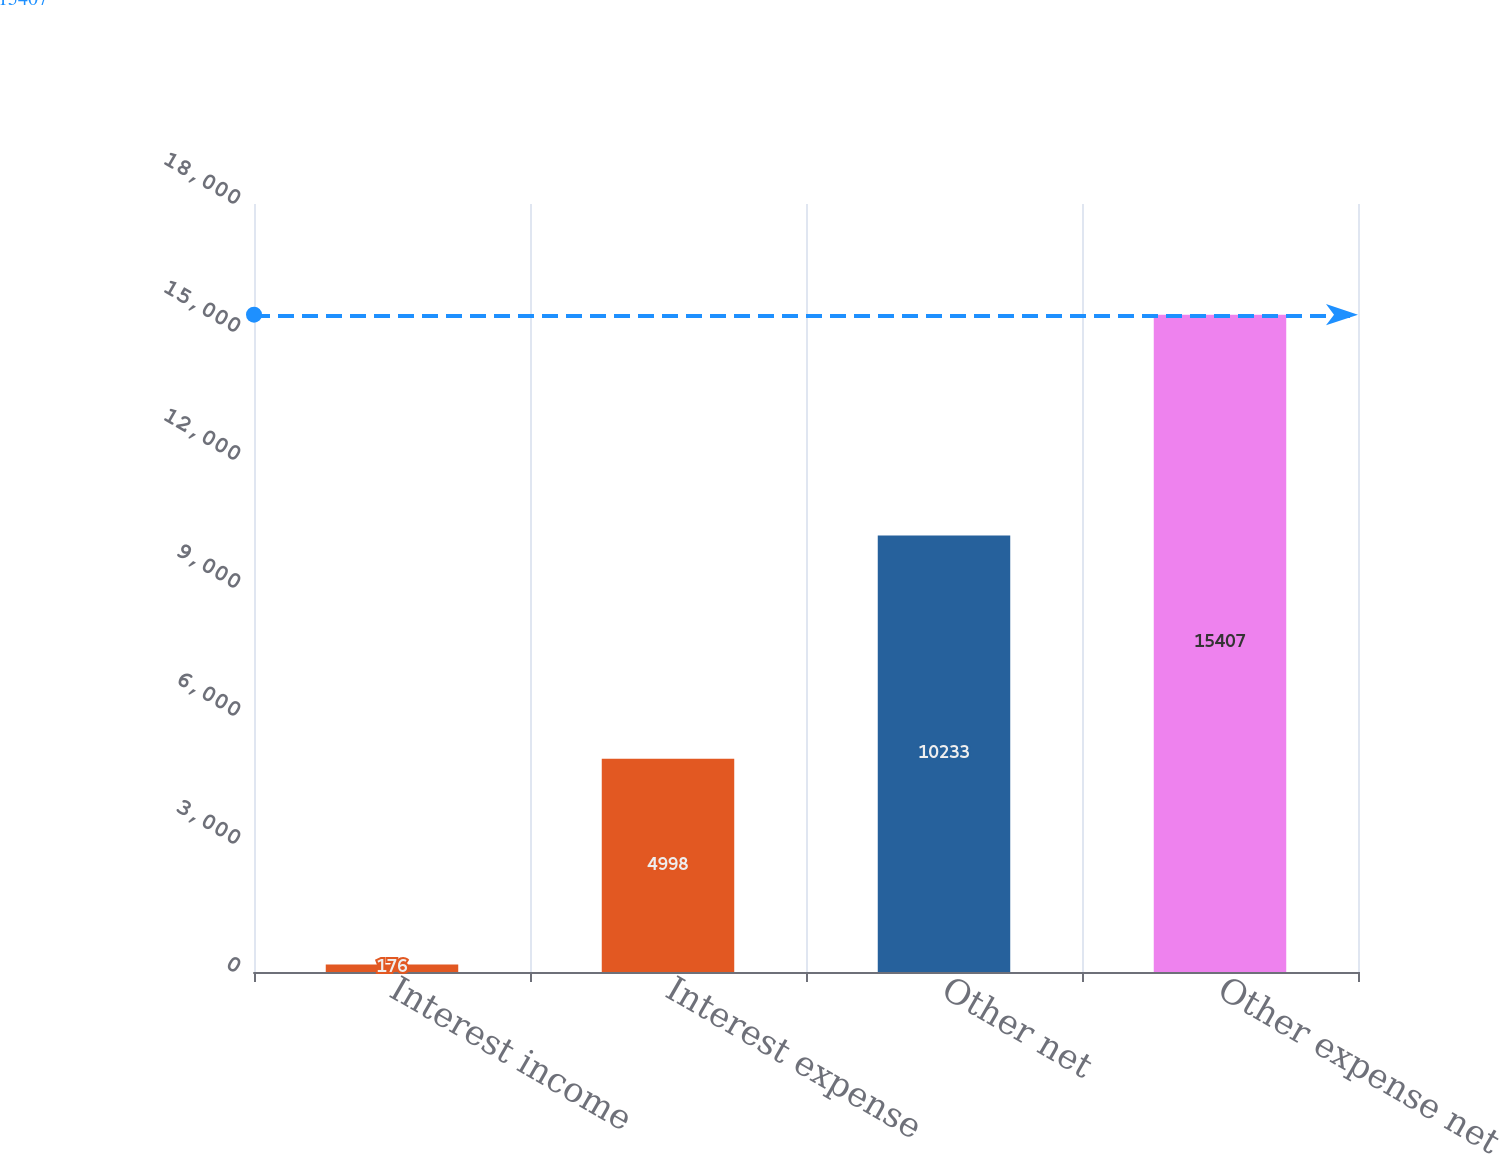<chart> <loc_0><loc_0><loc_500><loc_500><bar_chart><fcel>Interest income<fcel>Interest expense<fcel>Other net<fcel>Other expense net<nl><fcel>176<fcel>4998<fcel>10233<fcel>15407<nl></chart> 